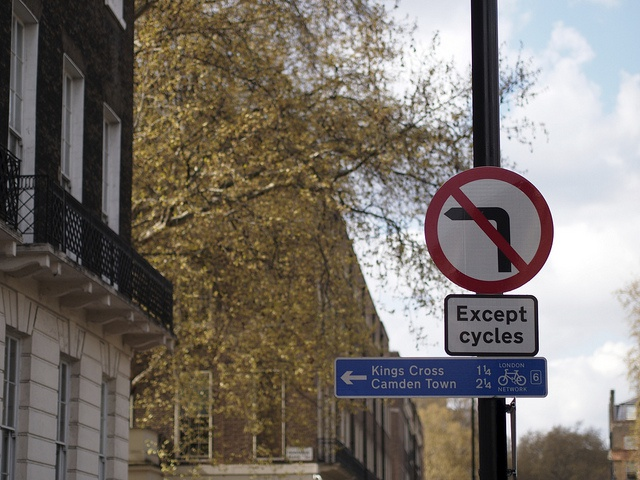Describe the objects in this image and their specific colors. I can see various objects in this image with different colors. 